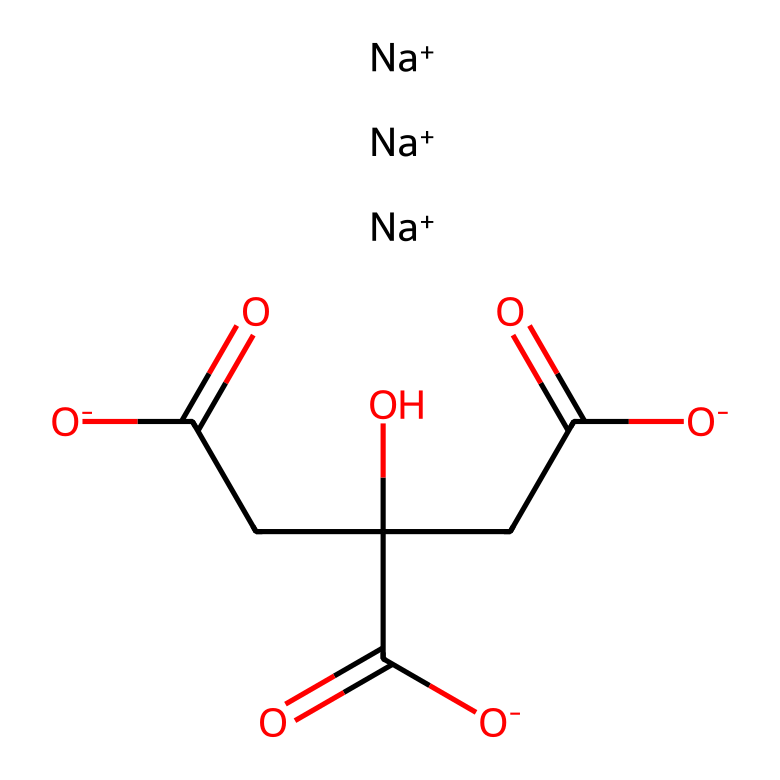What are the cations present in this compound? The SMILES representation shows three instances of sodium ions (Na+), indicating that these are the cations present.
Answer: sodium How many carboxylate groups are in this structure? By analyzing the structure, there are three instances of carboxylate groups (O=C([O-])) present in the compound.
Answer: three What is the total number of hydroxyl (–OH) groups in this compound? The structural formula indicates the presence of two hydroxyl groups as part of the carbon chain, thus the total count is two.
Answer: two What type of compound is represented by this SMILES structure? The structure includes electrolytes with sodium ions and multiple acidic groups, indicating that it is a medicinal compound related to hydration.
Answer: electrolyte Which functional group is prominently featured in this compound for hydration? The presence of multiple carboxylate (–COO-) groups plays a significant role in hydration and electrolyte balance in sports drinks.
Answer: carboxylate What is the total number of carbon atoms in this compound? Counting the carbon atoms represented in the structure reveals a total of six carbon atoms in the entire compound.
Answer: six 